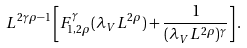<formula> <loc_0><loc_0><loc_500><loc_500>L ^ { 2 \gamma \rho - 1 } \left [ F ^ { \gamma } _ { 1 , 2 \rho } ( \lambda _ { V } L ^ { 2 \rho } ) + \frac { 1 } { ( \lambda _ { V } L ^ { 2 \rho } ) ^ { \gamma } } \right ] .</formula> 